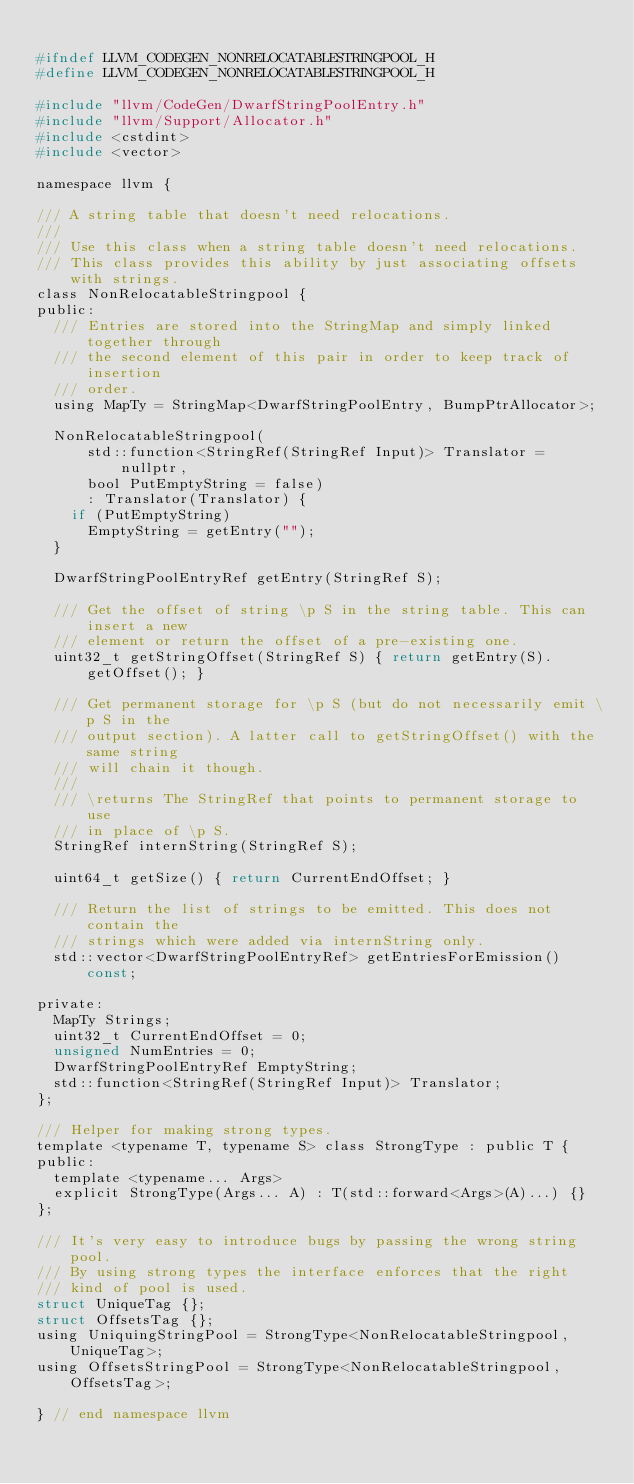<code> <loc_0><loc_0><loc_500><loc_500><_C_>
#ifndef LLVM_CODEGEN_NONRELOCATABLESTRINGPOOL_H
#define LLVM_CODEGEN_NONRELOCATABLESTRINGPOOL_H

#include "llvm/CodeGen/DwarfStringPoolEntry.h"
#include "llvm/Support/Allocator.h"
#include <cstdint>
#include <vector>

namespace llvm {

/// A string table that doesn't need relocations.
///
/// Use this class when a string table doesn't need relocations.
/// This class provides this ability by just associating offsets with strings.
class NonRelocatableStringpool {
public:
  /// Entries are stored into the StringMap and simply linked together through
  /// the second element of this pair in order to keep track of insertion
  /// order.
  using MapTy = StringMap<DwarfStringPoolEntry, BumpPtrAllocator>;

  NonRelocatableStringpool(
      std::function<StringRef(StringRef Input)> Translator = nullptr,
      bool PutEmptyString = false)
      : Translator(Translator) {
    if (PutEmptyString)
      EmptyString = getEntry("");
  }

  DwarfStringPoolEntryRef getEntry(StringRef S);

  /// Get the offset of string \p S in the string table. This can insert a new
  /// element or return the offset of a pre-existing one.
  uint32_t getStringOffset(StringRef S) { return getEntry(S).getOffset(); }

  /// Get permanent storage for \p S (but do not necessarily emit \p S in the
  /// output section). A latter call to getStringOffset() with the same string
  /// will chain it though.
  ///
  /// \returns The StringRef that points to permanent storage to use
  /// in place of \p S.
  StringRef internString(StringRef S);

  uint64_t getSize() { return CurrentEndOffset; }

  /// Return the list of strings to be emitted. This does not contain the
  /// strings which were added via internString only.
  std::vector<DwarfStringPoolEntryRef> getEntriesForEmission() const;

private:
  MapTy Strings;
  uint32_t CurrentEndOffset = 0;
  unsigned NumEntries = 0;
  DwarfStringPoolEntryRef EmptyString;
  std::function<StringRef(StringRef Input)> Translator;
};

/// Helper for making strong types.
template <typename T, typename S> class StrongType : public T {
public:
  template <typename... Args>
  explicit StrongType(Args... A) : T(std::forward<Args>(A)...) {}
};

/// It's very easy to introduce bugs by passing the wrong string pool.
/// By using strong types the interface enforces that the right
/// kind of pool is used.
struct UniqueTag {};
struct OffsetsTag {};
using UniquingStringPool = StrongType<NonRelocatableStringpool, UniqueTag>;
using OffsetsStringPool = StrongType<NonRelocatableStringpool, OffsetsTag>;

} // end namespace llvm
</code> 